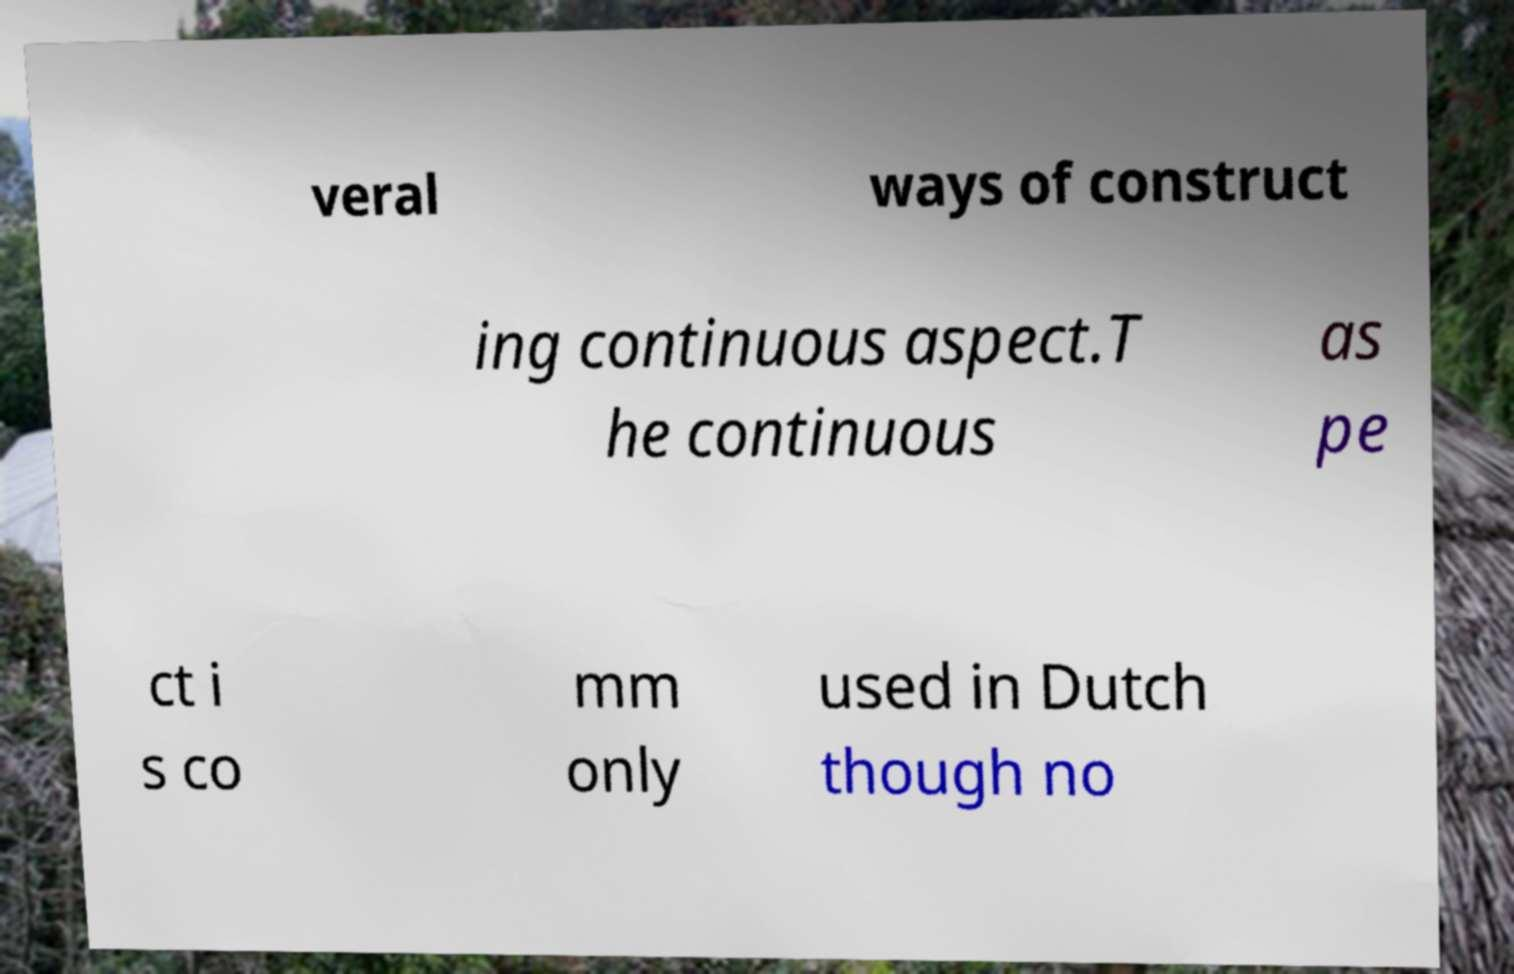Could you extract and type out the text from this image? veral ways of construct ing continuous aspect.T he continuous as pe ct i s co mm only used in Dutch though no 